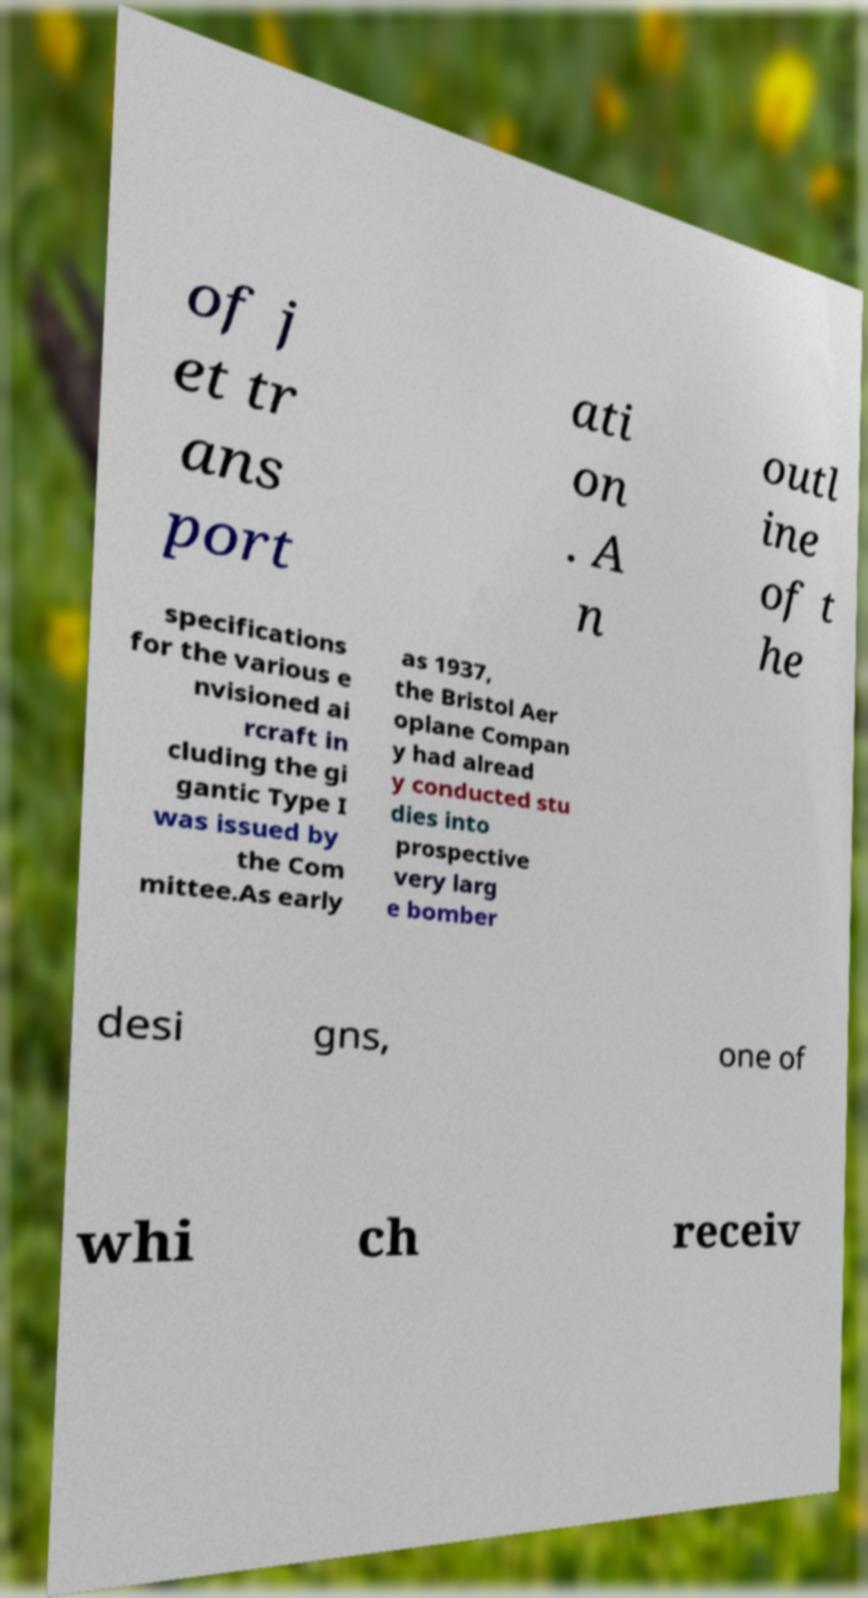Please identify and transcribe the text found in this image. of j et tr ans port ati on . A n outl ine of t he specifications for the various e nvisioned ai rcraft in cluding the gi gantic Type I was issued by the Com mittee.As early as 1937, the Bristol Aer oplane Compan y had alread y conducted stu dies into prospective very larg e bomber desi gns, one of whi ch receiv 